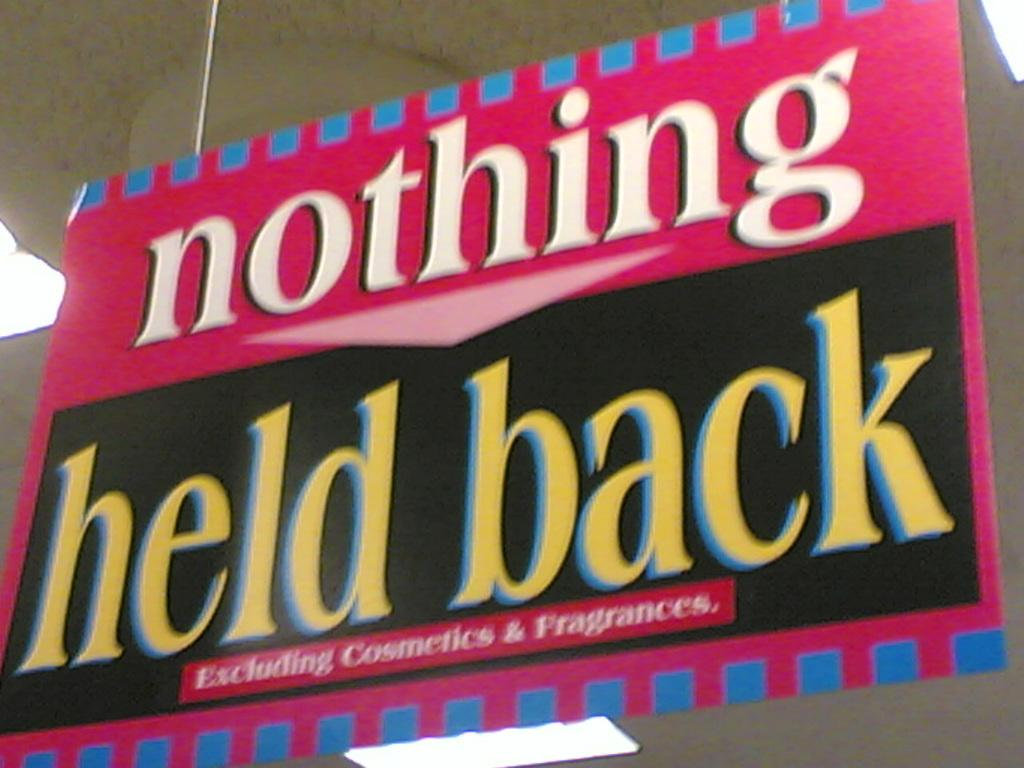<image>
Create a compact narrative representing the image presented. A store has a sale that excludes cosmetics and fragrances. 